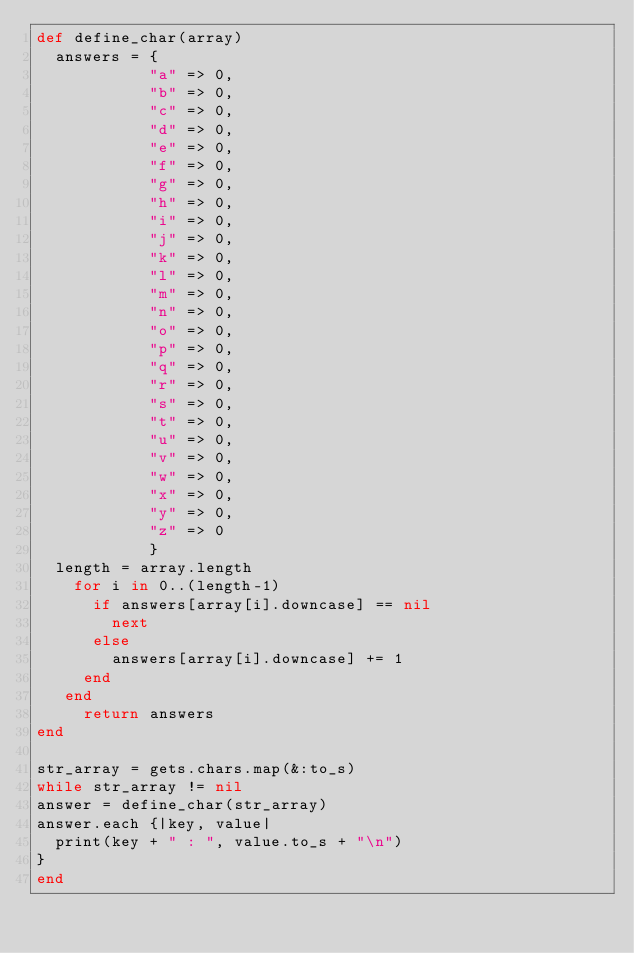<code> <loc_0><loc_0><loc_500><loc_500><_Ruby_>def define_char(array)
  answers = {
            "a" => 0,
            "b" => 0,
            "c" => 0,
            "d" => 0,
            "e" => 0,
            "f" => 0,
            "g" => 0,
            "h" => 0,
            "i" => 0,
            "j" => 0,
            "k" => 0,
            "l" => 0,
            "m" => 0,
            "n" => 0,
            "o" => 0,
            "p" => 0,
            "q" => 0,
            "r" => 0,
            "s" => 0,
            "t" => 0,
            "u" => 0,
            "v" => 0,
            "w" => 0,
            "x" => 0,
            "y" => 0,
            "z" => 0
            }
  length = array.length
    for i in 0..(length-1)
      if answers[array[i].downcase] == nil
        next
      else
        answers[array[i].downcase] += 1
     end
   end
     return answers
end

str_array = gets.chars.map(&:to_s)
while str_array != nil
answer = define_char(str_array)
answer.each {|key, value|
  print(key + " : ", value.to_s + "\n")
}
end</code> 